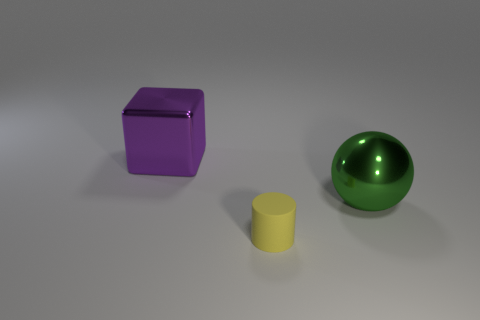Are there more cubes in front of the purple metallic block than big blocks behind the green metal object?
Give a very brief answer. No. There is a big metallic thing that is to the left of the large shiny thing to the right of the large purple metal thing; what is its color?
Your answer should be compact. Purple. Is there a object of the same color as the block?
Give a very brief answer. No. What is the size of the object that is in front of the large shiny thing that is on the right side of the metal thing that is on the left side of the big green metallic ball?
Keep it short and to the point. Small. There is a small yellow thing; what shape is it?
Make the answer very short. Cylinder. There is a big metallic thing that is behind the large green object; what number of big metal objects are to the right of it?
Offer a terse response. 1. How many other things are there of the same material as the block?
Provide a short and direct response. 1. Is the sphere that is behind the tiny rubber cylinder made of the same material as the thing that is on the left side of the matte thing?
Ensure brevity in your answer.  Yes. Are there any other things that are the same shape as the big green shiny thing?
Your answer should be compact. No. Does the purple block have the same material as the big thing that is right of the tiny matte cylinder?
Provide a succinct answer. Yes. 